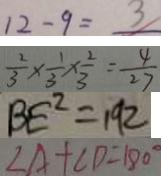<formula> <loc_0><loc_0><loc_500><loc_500>1 2 - 9 = 3 
 \frac { 2 } { 3 } \times \frac { 1 } { 3 } \times \frac { 2 } { 3 } = \frac { 4 } { 2 7 } 
 B E ^ { 2 } = 1 9 2 
 \angle A + \angle D = 1 8 0 ^ { \circ }</formula> 